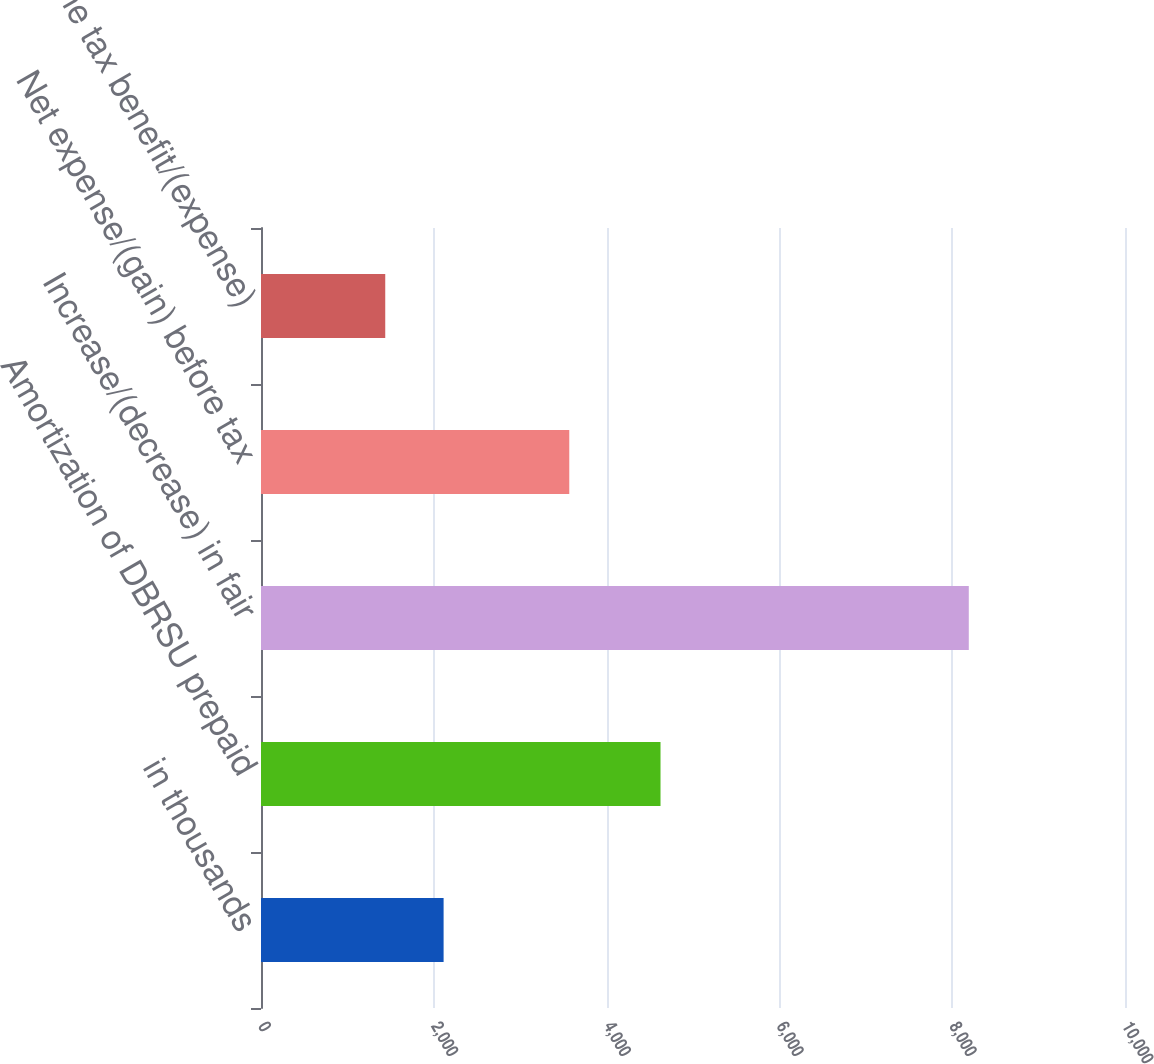<chart> <loc_0><loc_0><loc_500><loc_500><bar_chart><fcel>in thousands<fcel>Amortization of DBRSU prepaid<fcel>Increase/(decrease) in fair<fcel>Net expense/(gain) before tax<fcel>Income tax benefit/(expense)<nl><fcel>2113.4<fcel>4624<fcel>8192<fcel>3568<fcel>1438<nl></chart> 